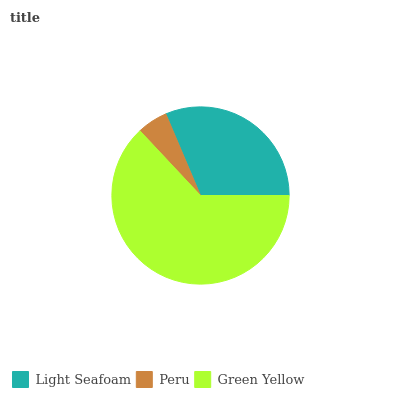Is Peru the minimum?
Answer yes or no. Yes. Is Green Yellow the maximum?
Answer yes or no. Yes. Is Green Yellow the minimum?
Answer yes or no. No. Is Peru the maximum?
Answer yes or no. No. Is Green Yellow greater than Peru?
Answer yes or no. Yes. Is Peru less than Green Yellow?
Answer yes or no. Yes. Is Peru greater than Green Yellow?
Answer yes or no. No. Is Green Yellow less than Peru?
Answer yes or no. No. Is Light Seafoam the high median?
Answer yes or no. Yes. Is Light Seafoam the low median?
Answer yes or no. Yes. Is Green Yellow the high median?
Answer yes or no. No. Is Peru the low median?
Answer yes or no. No. 